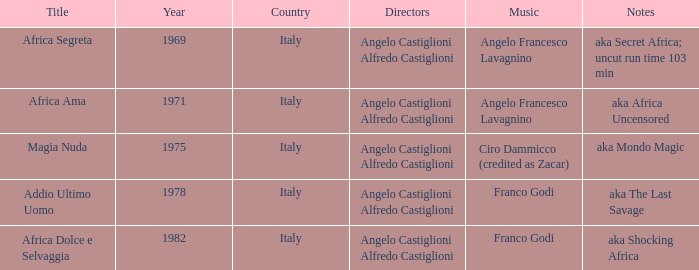Which melody features the notes of aka africa uncensored? Angelo Francesco Lavagnino. 